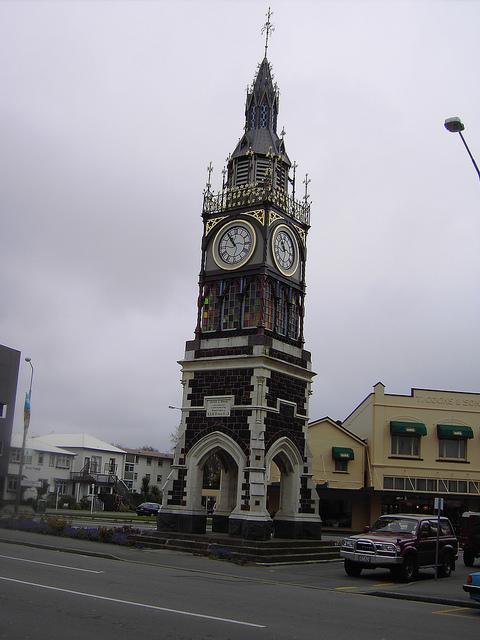What kind of building is this?
Write a very short answer. Clock tower. What time is shown on the clock?
Keep it brief. 10:55. What is the picture taken?
Answer briefly. Clock tower. Are there mountains behind this city?
Be succinct. No. What time is it on the clock?
Concise answer only. 10:55. What color is the sky?
Short answer required. Gray. Is the street lamp on?
Be succinct. No. How many clocks are there?
Concise answer only. 2. What time is it?
Keep it brief. 10:55. Was this clock tower built recently?
Short answer required. No. Do you see a face?
Quick response, please. No. What time does it show on both clocks?
Quick response, please. 10:55. What is at the top of the tower?
Answer briefly. Clock. 